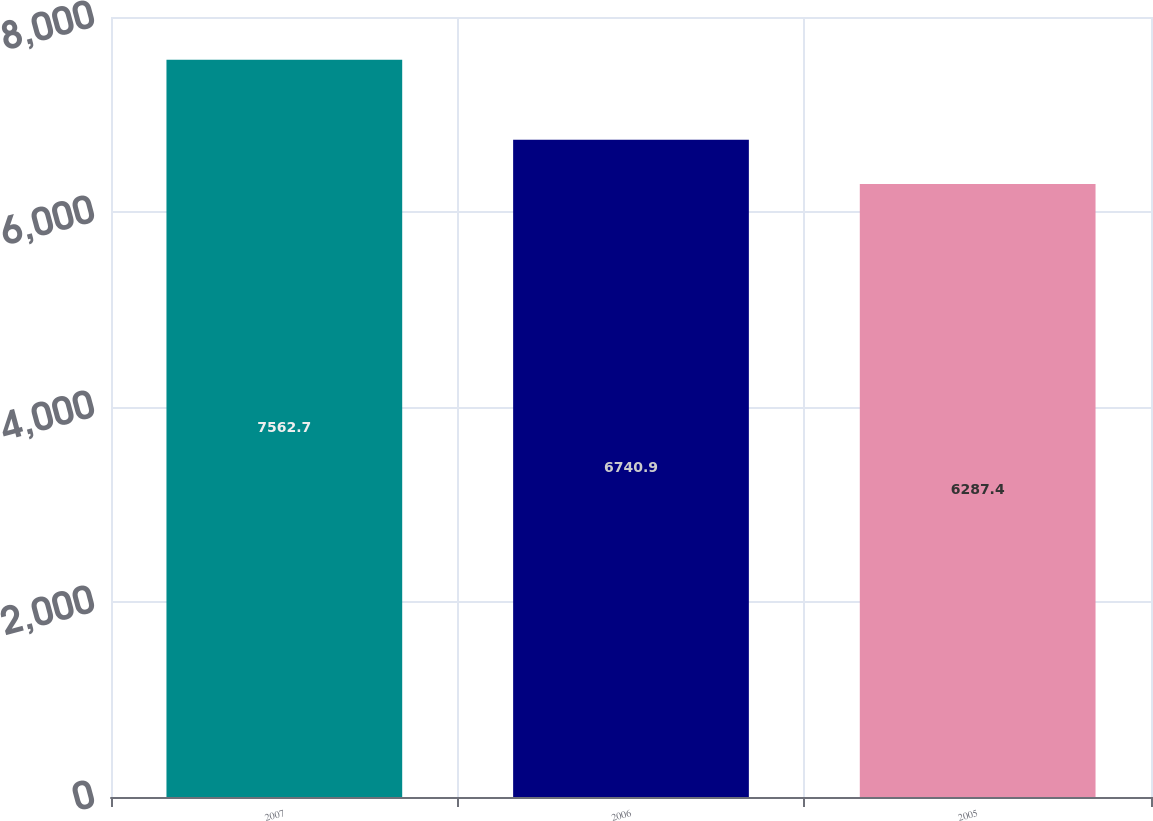Convert chart to OTSL. <chart><loc_0><loc_0><loc_500><loc_500><bar_chart><fcel>2007<fcel>2006<fcel>2005<nl><fcel>7562.7<fcel>6740.9<fcel>6287.4<nl></chart> 